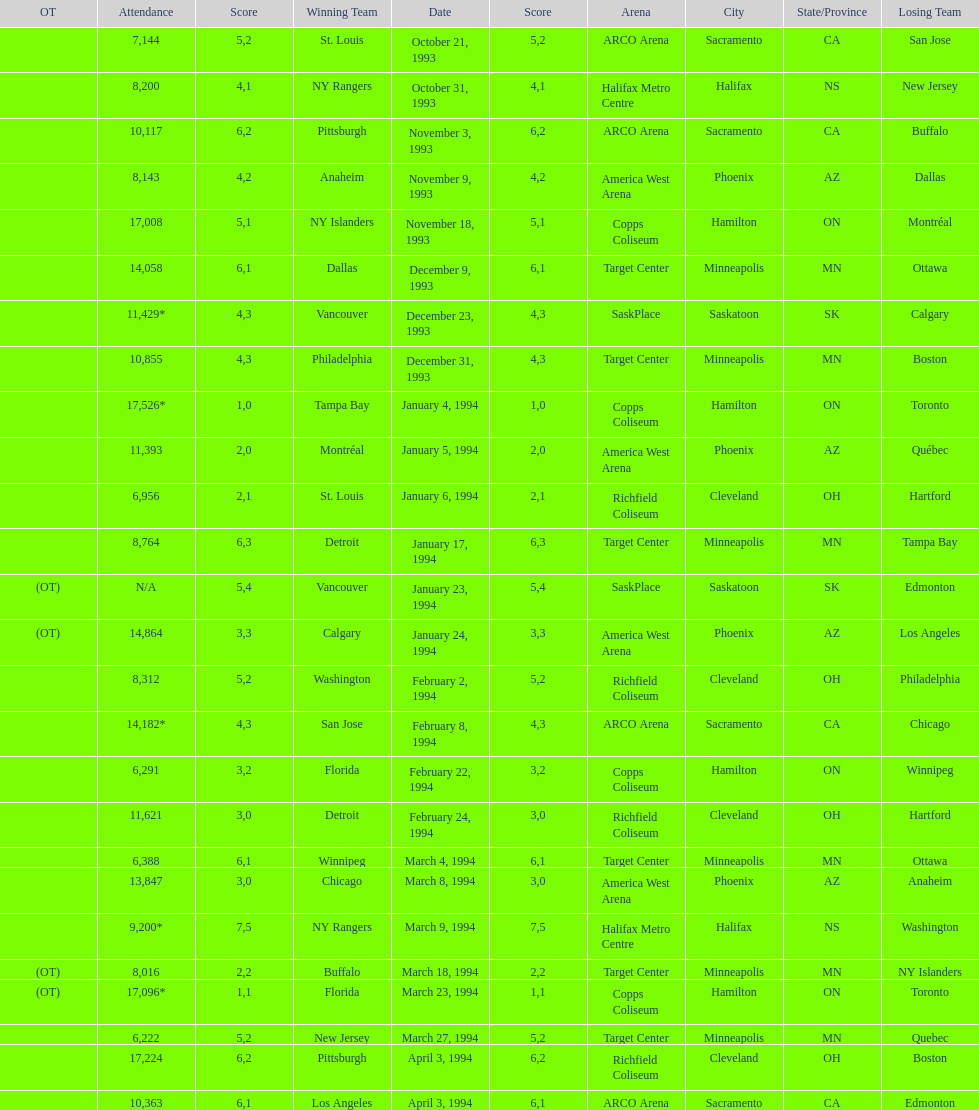Did dallas or ottawa win the december 9, 1993 game? Dallas. 